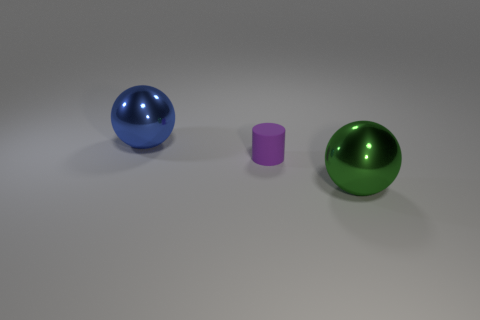Add 1 blue rubber balls. How many objects exist? 4 Subtract all cylinders. How many objects are left? 2 Add 2 blue spheres. How many blue spheres exist? 3 Subtract 0 blue cylinders. How many objects are left? 3 Subtract all blue spheres. Subtract all blue metallic things. How many objects are left? 1 Add 3 cylinders. How many cylinders are left? 4 